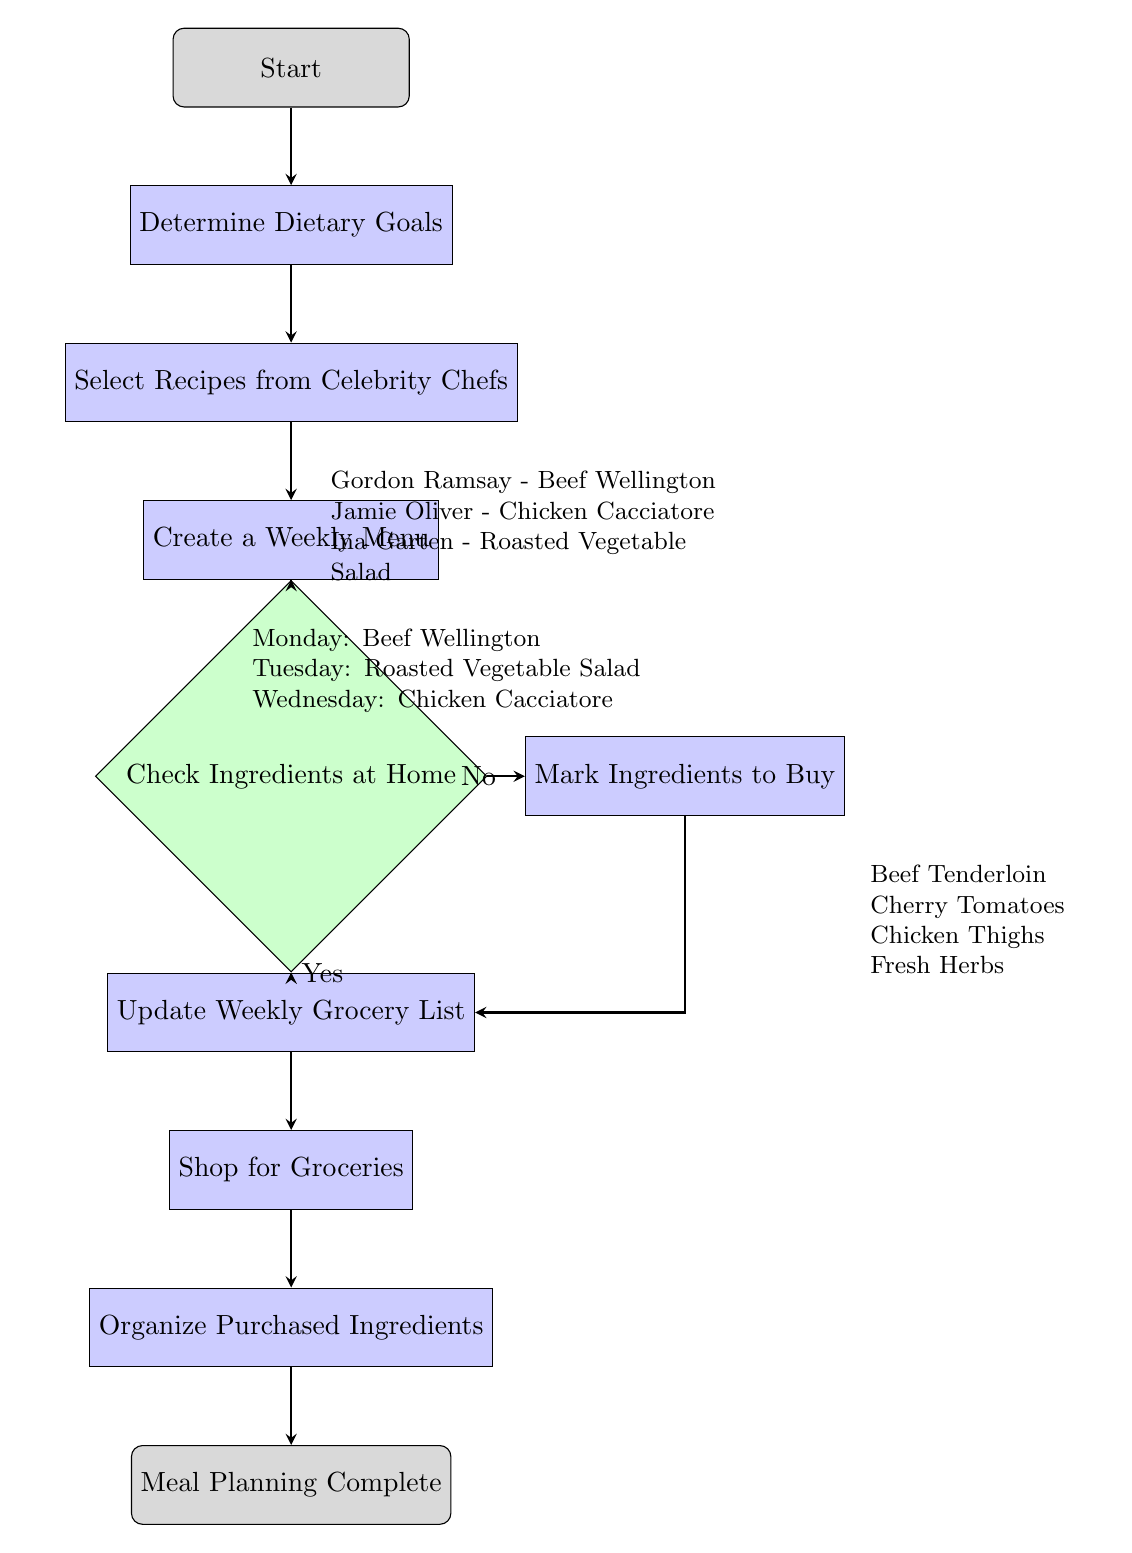What is the first step in the meal planning process? The first step in the flow chart is labeled "Start," then moves to "Determine Dietary Goals." Therefore, the first actionable step is to "Determine Dietary Goals."
Answer: Determine Dietary Goals How many recipes are selected from celebrity chefs? The flow chart includes one box titled "Select Recipes from Celebrity Chefs" which lists three specific recipes. Thus, three recipes are selected.
Answer: 3 What ingredient should be bought if ingredients are missing at home? If the ingredients are missing at home, the process flow goes to "Mark Ingredients to Buy," which specifies four ingredients that should be purchased. Thus, one of the ingredients to buy is "Beef Tenderloin," but all listed ingredients can be bought if needed.
Answer: Beef Tenderloin If there are ingredients available at home, what is the next step? The decision node "Check Ingredients at Home" leads to "Update Weekly Grocery List" if there are ingredients available. Hence, the next step is to update the grocery list.
Answer: Update Weekly Grocery List What is done after shopping for groceries? The flow chart shows that after "Shop for Groceries," the next step is to "Organize Purchased Ingredients." Hence, the action taken is to organize the ingredients.
Answer: Organize Purchased Ingredients What is the last step in this meal planning process? At the end of the flow chart, the last node is labeled "Meal Planning Complete," indicating the completion of the entire process. Therefore, the last step is achieving meal planning completion.
Answer: Meal Planning Complete How are the recipes categorized throughout the week? The "Create a Weekly Menu" process categorizes the recipes by day, listing specific recipes for Monday, Tuesday, and Wednesday. Thus, the categorization is done by assigning one specific recipe to each day.
Answer: By day What happens if there are no ingredients at home? If there are no ingredients at home, the flow chart directs to "Mark Ingredients to Buy," which leads to procuring specific items needed for the recipes, before proceeding to update the grocery list. Therefore, if there are no ingredients, the user must mark ingredients to buy.
Answer: Mark Ingredients to Buy Which chef is associated with the recipe on Monday? The "Create a Weekly Menu" node specifies that Monday's recipe is "Beef Wellington," which is associated with Chef Gordon Ramsay. Hence, the chef associated with Monday's recipe is Gordon Ramsay.
Answer: Gordon Ramsay 